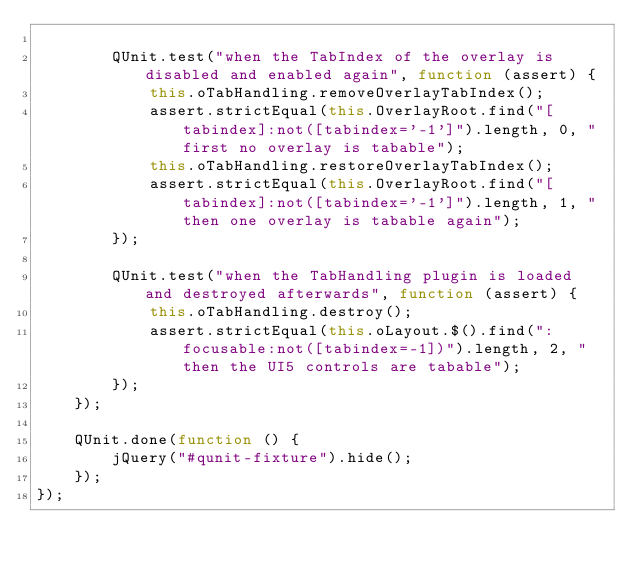Convert code to text. <code><loc_0><loc_0><loc_500><loc_500><_JavaScript_>
		QUnit.test("when the TabIndex of the overlay is disabled and enabled again", function (assert) {
			this.oTabHandling.removeOverlayTabIndex();
			assert.strictEqual(this.OverlayRoot.find("[tabindex]:not([tabindex='-1']").length, 0, "first no overlay is tabable");
			this.oTabHandling.restoreOverlayTabIndex();
			assert.strictEqual(this.OverlayRoot.find("[tabindex]:not([tabindex='-1']").length, 1, "then one overlay is tabable again");
		});

		QUnit.test("when the TabHandling plugin is loaded and destroyed afterwards", function (assert) {
			this.oTabHandling.destroy();
			assert.strictEqual(this.oLayout.$().find(":focusable:not([tabindex=-1])").length, 2, "then the UI5 controls are tabable");
		});
	});

	QUnit.done(function () {
		jQuery("#qunit-fixture").hide();
	});
});
</code> 